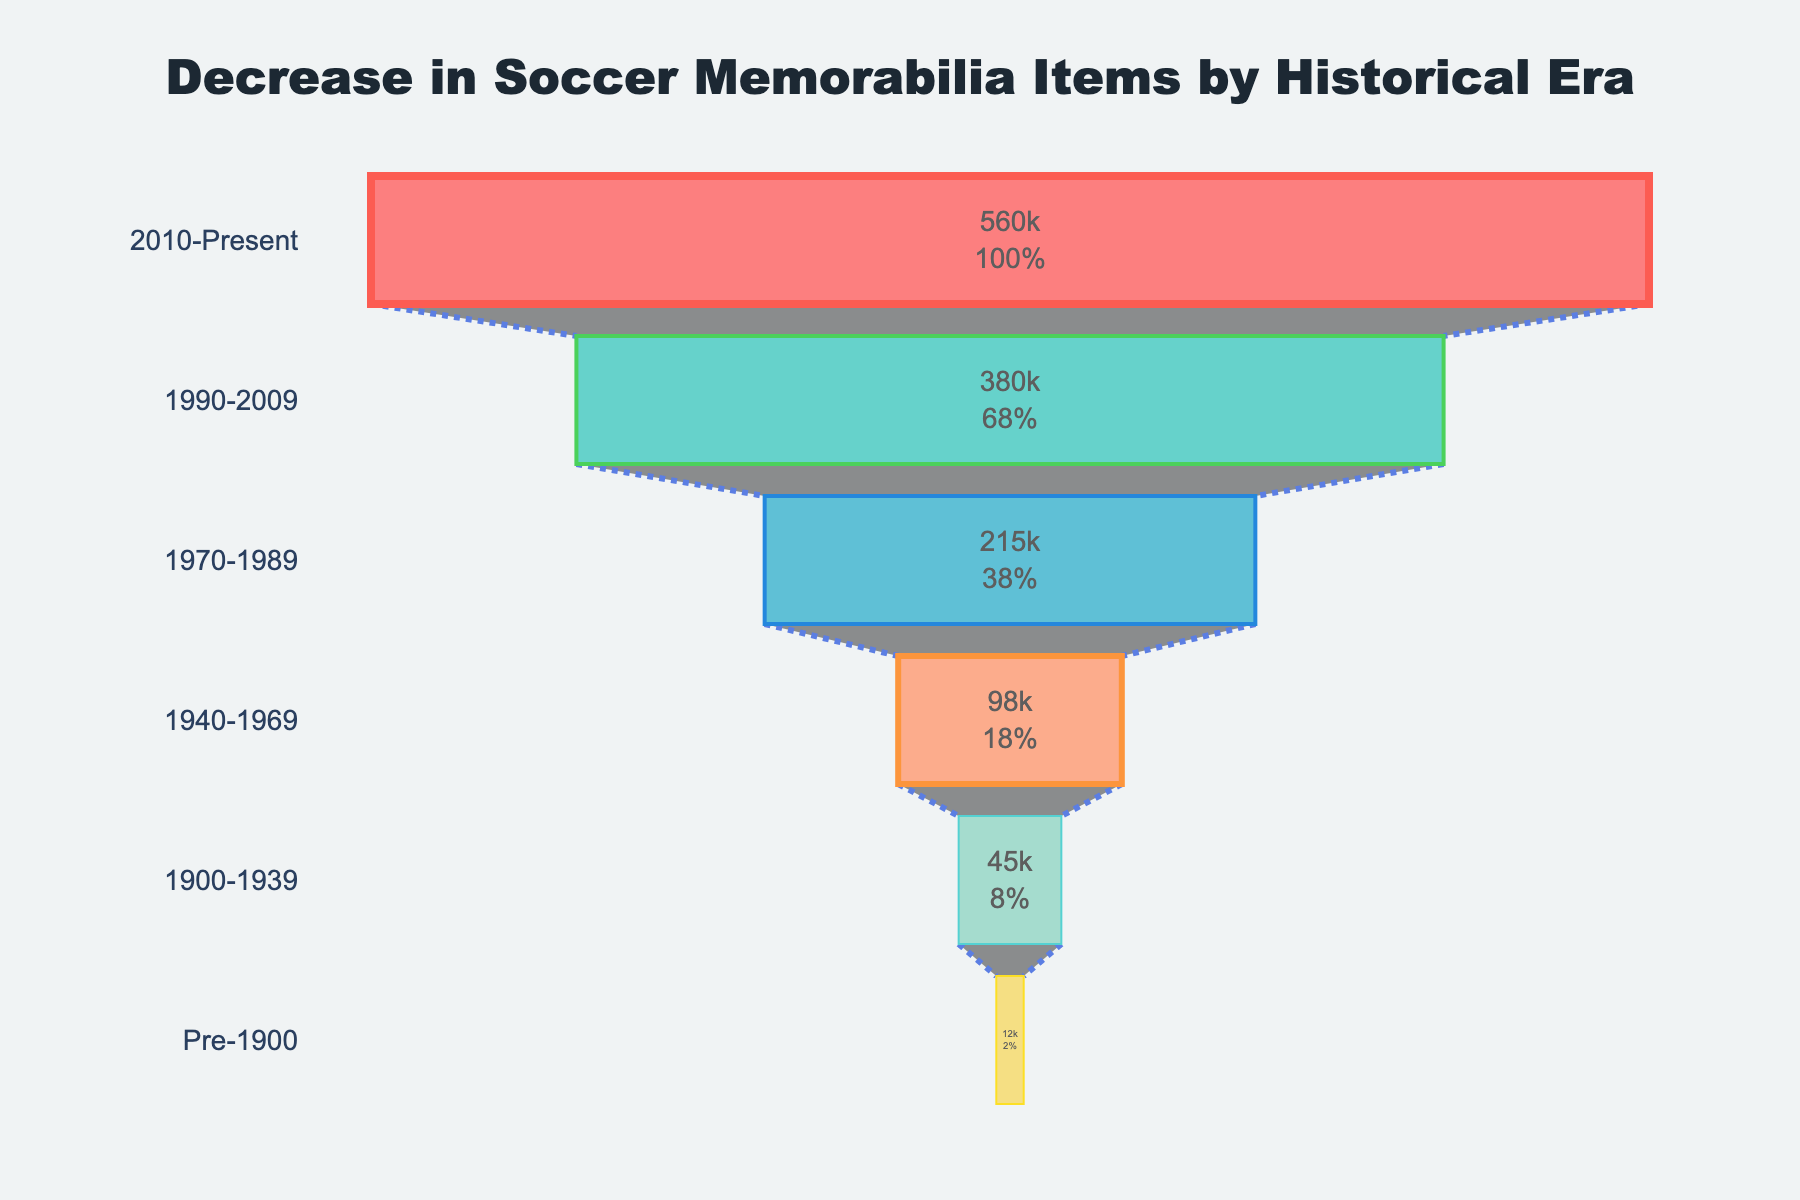Which era has the highest number of available soccer memorabilia items? By looking at the funnel chart, identify the era with the largest section representing the number of items. The era with the largest section is the current one.
Answer: 2010-Present What's the total number of available soccer memorabilia items in the 20th century? The 20th century includes the periods 1900-1939, 1940-1969, 1970-1989, and 1990-2009. Sum their available items: 45000 + 98000 + 215000 + 380000 = 738000
Answer: 738000 Which era saw the greatest increase in the number of available soccer memorabilia items compared to the previous era? Calculate the difference between each era and the one that precedes it, then find the largest increase: (1940-1969 to 1970-1989) 215000 - 98000 = 117000; (1970-1989 to 1990-2009) 380000 - 215000 = 165000; (1990-2009 to 2010-Present) 560000 - 380000 = 180000. The greatest increase is from 1990-2009 to 2010-Present.
Answer: 1990-2009 to 2010-Present Is the number of soccer memorabilia items available in the era Pre-1900 less than 50% of the items in the era 1940-1969? Compare the Pre-1900 number to half of the 1940-1969 number: 12000 < (98000 / 2) = 12000 < 49000. Thus, Pre-1900 is less than 50% of 1940-1969.
Answer: Yes How does the number of available items in 1970-1989 compare to the total number available in 1900-1939 and Pre-1900 combined? First, sum the items for 1900-1939 and Pre-1900: 45000 + 12000 = 57000. Compare it to 215000 from 1970-1989: 215000 > 57000.
Answer: 1970-1989 is greater What percentage of the total number of soccer memorabilia items does the era 2010-Present represent? First, sum the total number of items: 12000 + 45000 + 98000 + 215000 + 380000 + 560000 = 1310000. Then calculate the percentage for 2010-Present: (560000 / 1310000) * 100 ≈ 42.75%.
Answer: ~42.75% Which era had an increase of more than 200% in available items compared to its previous era? Check the increases in percentage for each era: (1940-1969 from 1900-1939) (98000-45000)/45000 ≈ 117.78%; (1970-1989 from 1940-1969) (215000-98000)/98000 ≈ 119.39%; (1990-2009 from 1970-1989) (380000-215000)/215000 ≈ 76.74%; (2010-Present from 1990-2009) (560000-380000)/380000 ≈ 47.37%. No era had an increase of more than 200%.
Answer: None 